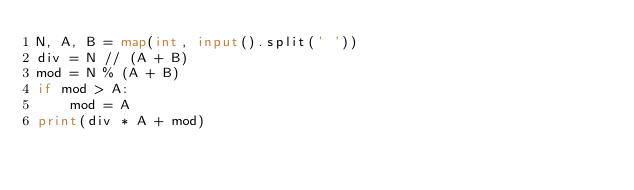<code> <loc_0><loc_0><loc_500><loc_500><_Python_>N, A, B = map(int, input().split(' '))
div = N // (A + B)
mod = N % (A + B)
if mod > A:
    mod = A
print(div * A + mod)</code> 